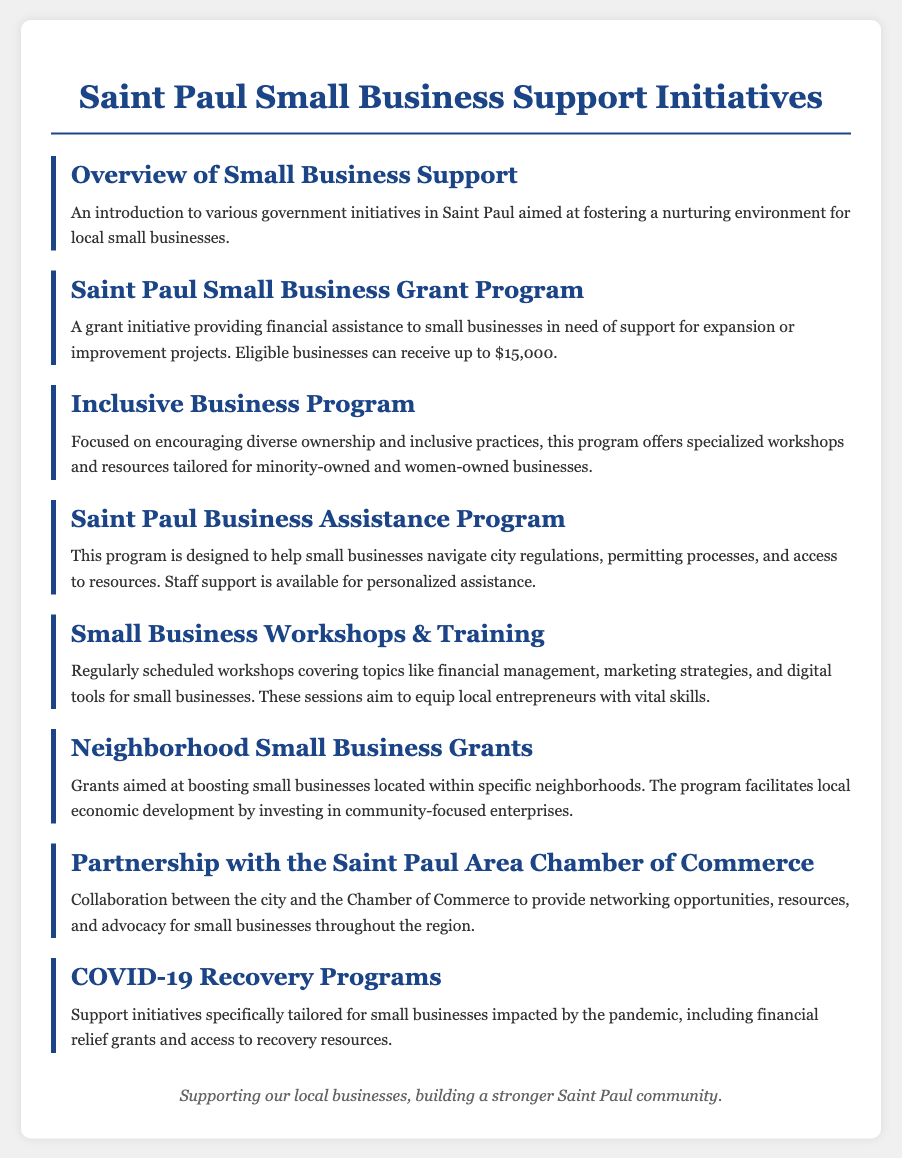What is the maximum amount provided by the Saint Paul Small Business Grant Program? The maximum amount provided by the grant program for small businesses is stated in the document as up to $15,000.
Answer: $15,000 What is the purpose of the Inclusive Business Program? The purpose of the Inclusive Business Program is to encourage diverse ownership and inclusive practices, offering specialized workshops and resources for certain business types.
Answer: Encourage diverse ownership What type of assistance does the Saint Paul Business Assistance Program provide? The assistance provided by this program focuses on helping small businesses navigate city regulations and access resources.
Answer: Navigate city regulations What specific neighborhood benefit does the Neighborhood Small Business Grants program offer? The program focuses on boosting small businesses located within specific neighborhoods, facilitating local economic development.
Answer: Boosting small businesses What is the main target audience for the Small Business Workshops & Training? The audience targeted by these workshops includes local entrepreneurs seeking to develop vital skills across various business topics.
Answer: Local entrepreneurs What kind of support do COVID-19 Recovery Programs provide? The recovery programs provide support initiatives such as financial relief grants and access to recovery resources specifically for businesses impacted by the pandemic.
Answer: Financial relief grants What organization partners with the city to support small businesses? The organization that partners with the city for supporting small businesses is the Saint Paul Area Chamber of Commerce.
Answer: Saint Paul Area Chamber of Commerce How are the workshops intended to benefit small businesses? The intention of the workshops is to equip entrepreneurs with skills in areas such as financial management and marketing strategies.
Answer: Equip entrepreneurs with skills 